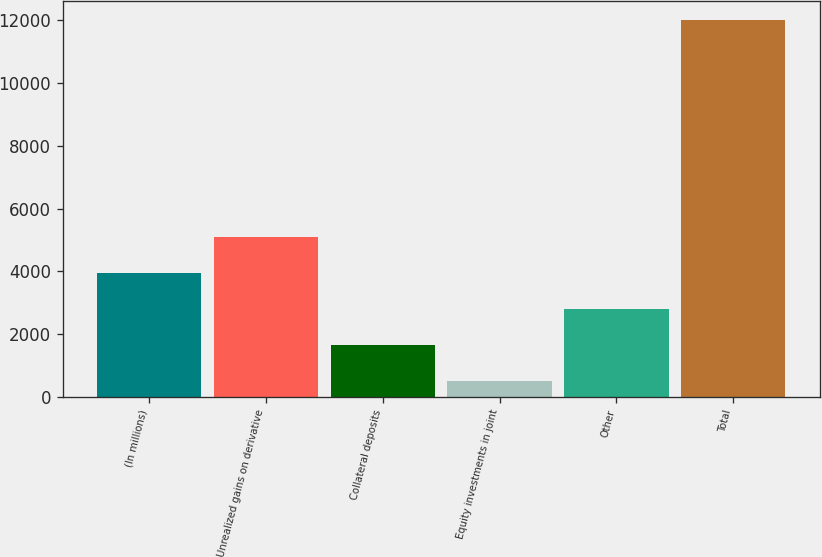Convert chart to OTSL. <chart><loc_0><loc_0><loc_500><loc_500><bar_chart><fcel>(In millions)<fcel>Unrealized gains on derivative<fcel>Collateral deposits<fcel>Equity investments in joint<fcel>Other<fcel>Total<nl><fcel>3951.3<fcel>5104.4<fcel>1645.1<fcel>492<fcel>2798.2<fcel>12023<nl></chart> 